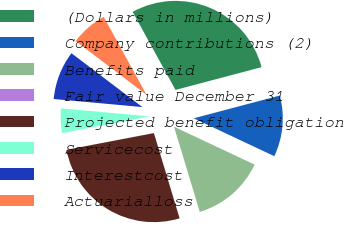Convert chart. <chart><loc_0><loc_0><loc_500><loc_500><pie_chart><fcel>(Dollars in millions)<fcel>Company contributions (2)<fcel>Benefits paid<fcel>Fair value December 31<fcel>Projected benefit obligation<fcel>Servicecost<fcel>Interestcost<fcel>Actuarialloss<nl><fcel>28.87%<fcel>11.11%<fcel>13.33%<fcel>0.01%<fcel>26.65%<fcel>4.45%<fcel>8.89%<fcel>6.67%<nl></chart> 